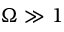<formula> <loc_0><loc_0><loc_500><loc_500>\Omega \gg 1</formula> 